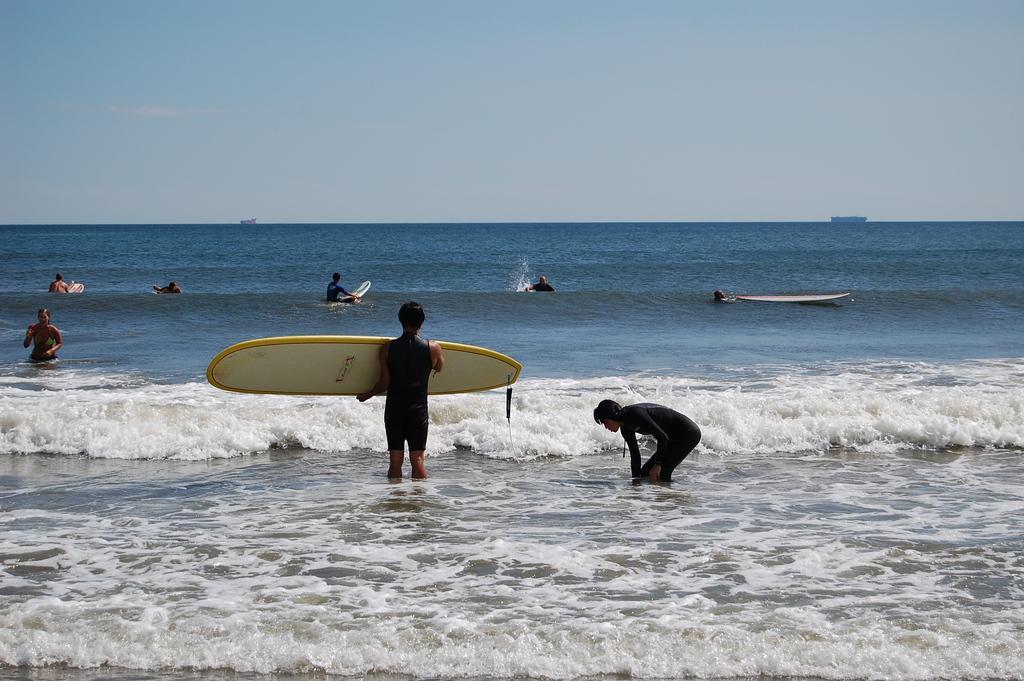Describe this image in one or two sentences. This picture shows a ocean where few people are standing and a man holding a surf boat in his hand and few are on the surf boat and we see a blue sky 